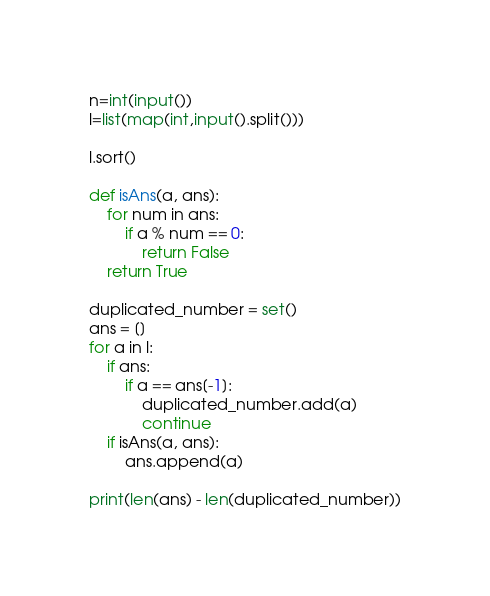Convert code to text. <code><loc_0><loc_0><loc_500><loc_500><_Python_>n=int(input())
l=list(map(int,input().split()))

l.sort()

def isAns(a, ans):
    for num in ans:
        if a % num == 0:
            return False
    return True

duplicated_number = set()
ans = []
for a in l:
    if ans:
        if a == ans[-1]:
            duplicated_number.add(a)
            continue
    if isAns(a, ans):
        ans.append(a)

print(len(ans) - len(duplicated_number))</code> 